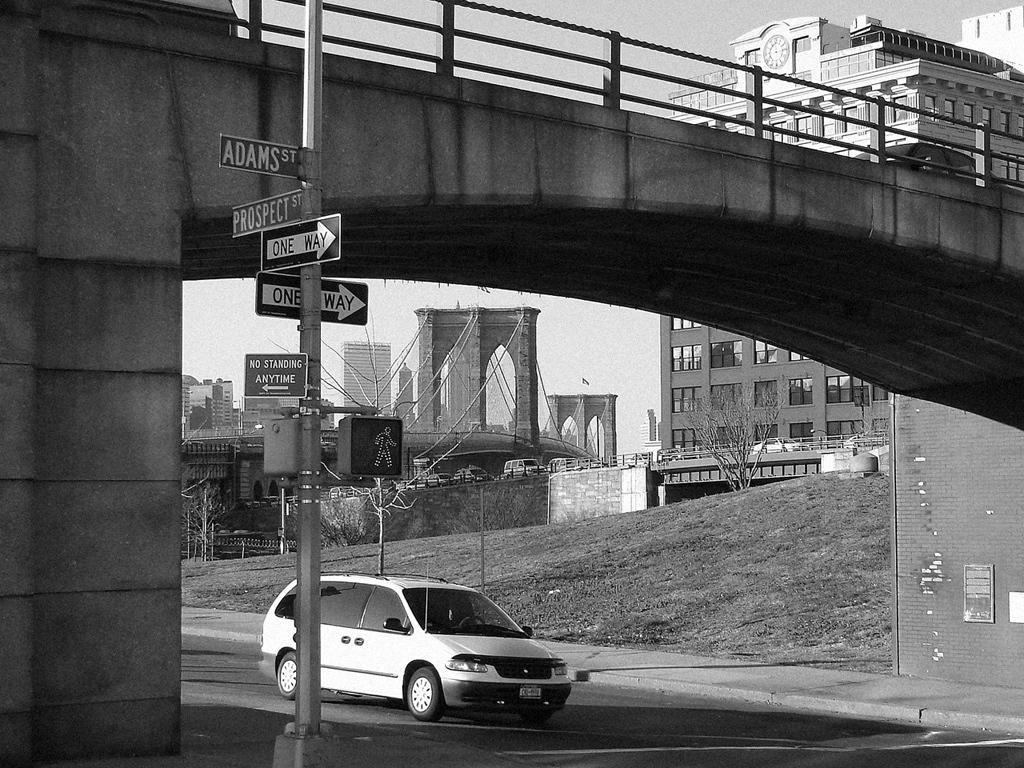Provide a one-sentence caption for the provided image. A car is waiting at a cross walk at the intersection of Adams St and Prospect St. 